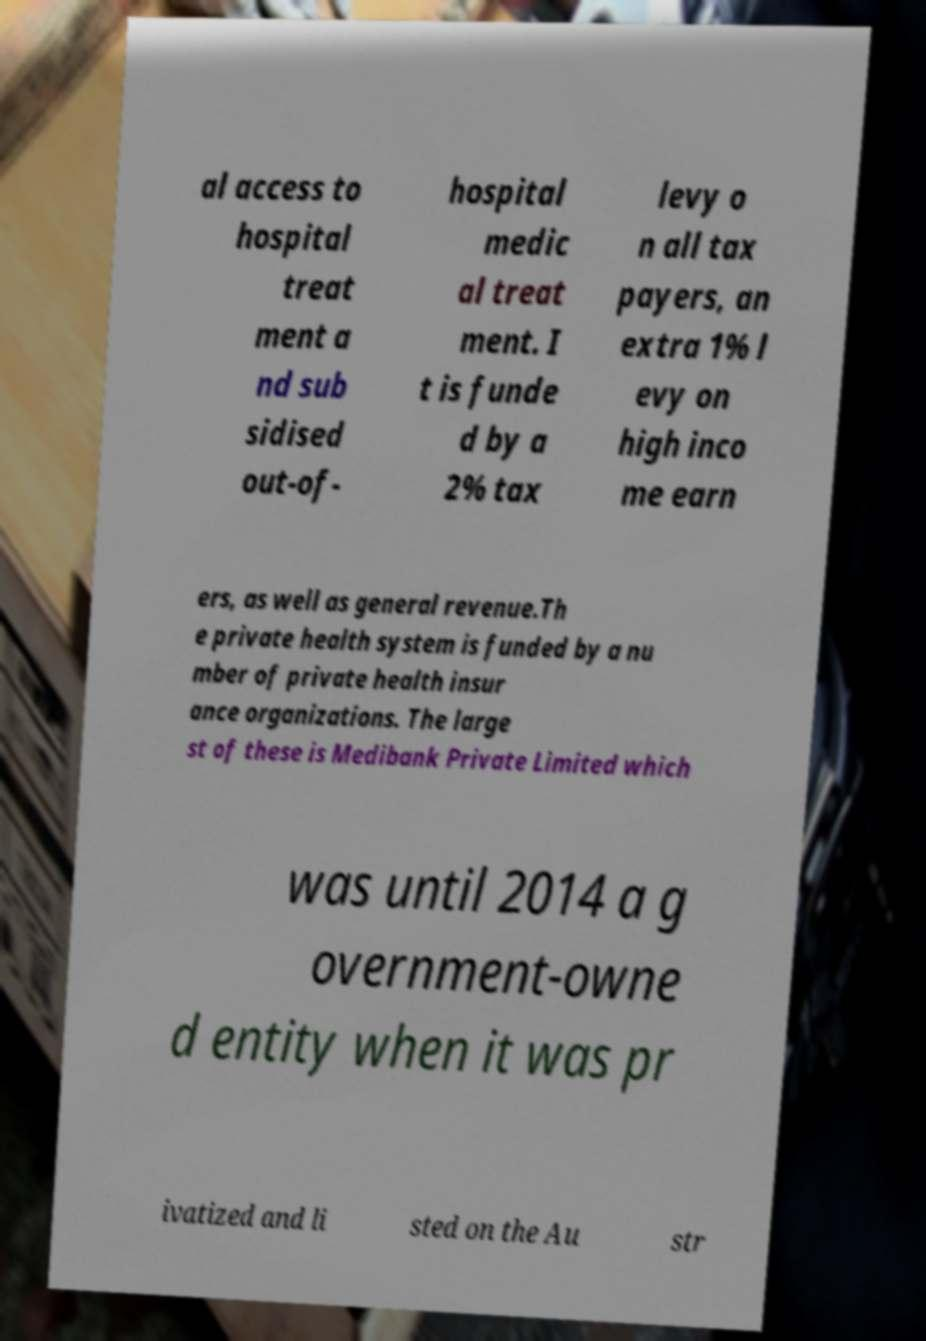For documentation purposes, I need the text within this image transcribed. Could you provide that? al access to hospital treat ment a nd sub sidised out-of- hospital medic al treat ment. I t is funde d by a 2% tax levy o n all tax payers, an extra 1% l evy on high inco me earn ers, as well as general revenue.Th e private health system is funded by a nu mber of private health insur ance organizations. The large st of these is Medibank Private Limited which was until 2014 a g overnment-owne d entity when it was pr ivatized and li sted on the Au str 